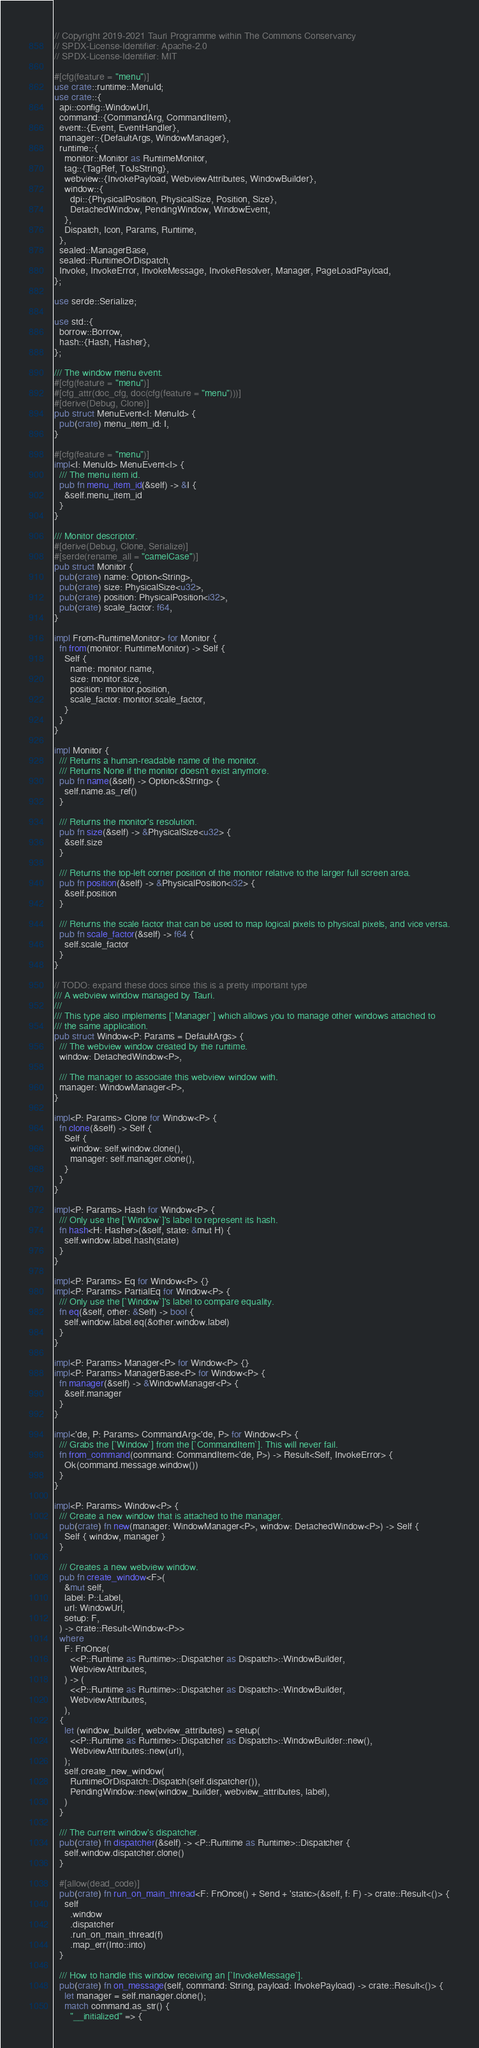Convert code to text. <code><loc_0><loc_0><loc_500><loc_500><_Rust_>// Copyright 2019-2021 Tauri Programme within The Commons Conservancy
// SPDX-License-Identifier: Apache-2.0
// SPDX-License-Identifier: MIT

#[cfg(feature = "menu")]
use crate::runtime::MenuId;
use crate::{
  api::config::WindowUrl,
  command::{CommandArg, CommandItem},
  event::{Event, EventHandler},
  manager::{DefaultArgs, WindowManager},
  runtime::{
    monitor::Monitor as RuntimeMonitor,
    tag::{TagRef, ToJsString},
    webview::{InvokePayload, WebviewAttributes, WindowBuilder},
    window::{
      dpi::{PhysicalPosition, PhysicalSize, Position, Size},
      DetachedWindow, PendingWindow, WindowEvent,
    },
    Dispatch, Icon, Params, Runtime,
  },
  sealed::ManagerBase,
  sealed::RuntimeOrDispatch,
  Invoke, InvokeError, InvokeMessage, InvokeResolver, Manager, PageLoadPayload,
};

use serde::Serialize;

use std::{
  borrow::Borrow,
  hash::{Hash, Hasher},
};

/// The window menu event.
#[cfg(feature = "menu")]
#[cfg_attr(doc_cfg, doc(cfg(feature = "menu")))]
#[derive(Debug, Clone)]
pub struct MenuEvent<I: MenuId> {
  pub(crate) menu_item_id: I,
}

#[cfg(feature = "menu")]
impl<I: MenuId> MenuEvent<I> {
  /// The menu item id.
  pub fn menu_item_id(&self) -> &I {
    &self.menu_item_id
  }
}

/// Monitor descriptor.
#[derive(Debug, Clone, Serialize)]
#[serde(rename_all = "camelCase")]
pub struct Monitor {
  pub(crate) name: Option<String>,
  pub(crate) size: PhysicalSize<u32>,
  pub(crate) position: PhysicalPosition<i32>,
  pub(crate) scale_factor: f64,
}

impl From<RuntimeMonitor> for Monitor {
  fn from(monitor: RuntimeMonitor) -> Self {
    Self {
      name: monitor.name,
      size: monitor.size,
      position: monitor.position,
      scale_factor: monitor.scale_factor,
    }
  }
}

impl Monitor {
  /// Returns a human-readable name of the monitor.
  /// Returns None if the monitor doesn't exist anymore.
  pub fn name(&self) -> Option<&String> {
    self.name.as_ref()
  }

  /// Returns the monitor's resolution.
  pub fn size(&self) -> &PhysicalSize<u32> {
    &self.size
  }

  /// Returns the top-left corner position of the monitor relative to the larger full screen area.
  pub fn position(&self) -> &PhysicalPosition<i32> {
    &self.position
  }

  /// Returns the scale factor that can be used to map logical pixels to physical pixels, and vice versa.
  pub fn scale_factor(&self) -> f64 {
    self.scale_factor
  }
}

// TODO: expand these docs since this is a pretty important type
/// A webview window managed by Tauri.
///
/// This type also implements [`Manager`] which allows you to manage other windows attached to
/// the same application.
pub struct Window<P: Params = DefaultArgs> {
  /// The webview window created by the runtime.
  window: DetachedWindow<P>,

  /// The manager to associate this webview window with.
  manager: WindowManager<P>,
}

impl<P: Params> Clone for Window<P> {
  fn clone(&self) -> Self {
    Self {
      window: self.window.clone(),
      manager: self.manager.clone(),
    }
  }
}

impl<P: Params> Hash for Window<P> {
  /// Only use the [`Window`]'s label to represent its hash.
  fn hash<H: Hasher>(&self, state: &mut H) {
    self.window.label.hash(state)
  }
}

impl<P: Params> Eq for Window<P> {}
impl<P: Params> PartialEq for Window<P> {
  /// Only use the [`Window`]'s label to compare equality.
  fn eq(&self, other: &Self) -> bool {
    self.window.label.eq(&other.window.label)
  }
}

impl<P: Params> Manager<P> for Window<P> {}
impl<P: Params> ManagerBase<P> for Window<P> {
  fn manager(&self) -> &WindowManager<P> {
    &self.manager
  }
}

impl<'de, P: Params> CommandArg<'de, P> for Window<P> {
  /// Grabs the [`Window`] from the [`CommandItem`]. This will never fail.
  fn from_command(command: CommandItem<'de, P>) -> Result<Self, InvokeError> {
    Ok(command.message.window())
  }
}

impl<P: Params> Window<P> {
  /// Create a new window that is attached to the manager.
  pub(crate) fn new(manager: WindowManager<P>, window: DetachedWindow<P>) -> Self {
    Self { window, manager }
  }

  /// Creates a new webview window.
  pub fn create_window<F>(
    &mut self,
    label: P::Label,
    url: WindowUrl,
    setup: F,
  ) -> crate::Result<Window<P>>
  where
    F: FnOnce(
      <<P::Runtime as Runtime>::Dispatcher as Dispatch>::WindowBuilder,
      WebviewAttributes,
    ) -> (
      <<P::Runtime as Runtime>::Dispatcher as Dispatch>::WindowBuilder,
      WebviewAttributes,
    ),
  {
    let (window_builder, webview_attributes) = setup(
      <<P::Runtime as Runtime>::Dispatcher as Dispatch>::WindowBuilder::new(),
      WebviewAttributes::new(url),
    );
    self.create_new_window(
      RuntimeOrDispatch::Dispatch(self.dispatcher()),
      PendingWindow::new(window_builder, webview_attributes, label),
    )
  }

  /// The current window's dispatcher.
  pub(crate) fn dispatcher(&self) -> <P::Runtime as Runtime>::Dispatcher {
    self.window.dispatcher.clone()
  }

  #[allow(dead_code)]
  pub(crate) fn run_on_main_thread<F: FnOnce() + Send + 'static>(&self, f: F) -> crate::Result<()> {
    self
      .window
      .dispatcher
      .run_on_main_thread(f)
      .map_err(Into::into)
  }

  /// How to handle this window receiving an [`InvokeMessage`].
  pub(crate) fn on_message(self, command: String, payload: InvokePayload) -> crate::Result<()> {
    let manager = self.manager.clone();
    match command.as_str() {
      "__initialized" => {</code> 